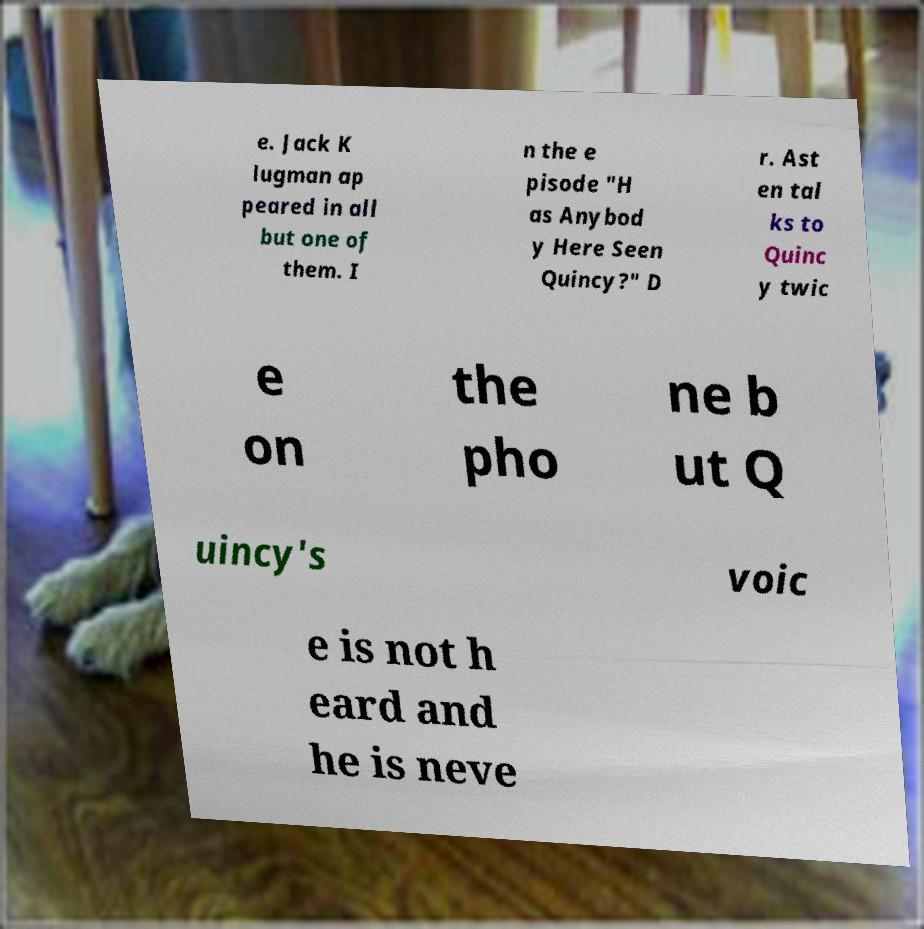Could you assist in decoding the text presented in this image and type it out clearly? e. Jack K lugman ap peared in all but one of them. I n the e pisode "H as Anybod y Here Seen Quincy?" D r. Ast en tal ks to Quinc y twic e on the pho ne b ut Q uincy's voic e is not h eard and he is neve 